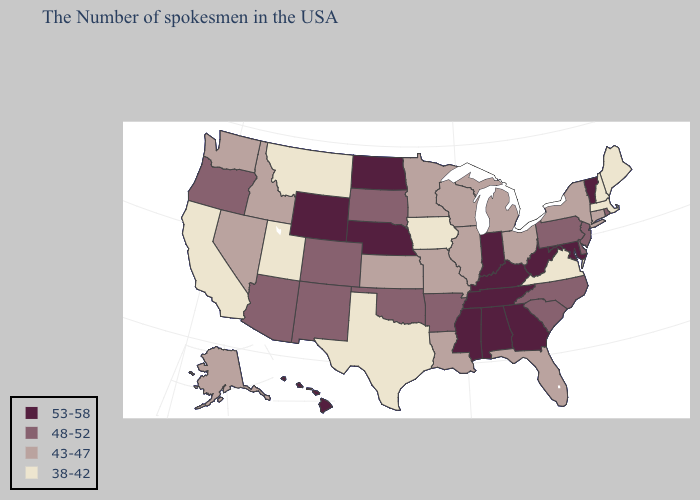Name the states that have a value in the range 38-42?
Write a very short answer. Maine, Massachusetts, New Hampshire, Virginia, Iowa, Texas, Utah, Montana, California. Does South Carolina have the highest value in the South?
Keep it brief. No. Which states have the highest value in the USA?
Write a very short answer. Vermont, Maryland, West Virginia, Georgia, Kentucky, Indiana, Alabama, Tennessee, Mississippi, Nebraska, North Dakota, Wyoming, Hawaii. What is the value of Mississippi?
Keep it brief. 53-58. Is the legend a continuous bar?
Write a very short answer. No. What is the lowest value in states that border Oklahoma?
Answer briefly. 38-42. Name the states that have a value in the range 53-58?
Keep it brief. Vermont, Maryland, West Virginia, Georgia, Kentucky, Indiana, Alabama, Tennessee, Mississippi, Nebraska, North Dakota, Wyoming, Hawaii. What is the value of Kentucky?
Short answer required. 53-58. Name the states that have a value in the range 43-47?
Be succinct. Connecticut, New York, Ohio, Florida, Michigan, Wisconsin, Illinois, Louisiana, Missouri, Minnesota, Kansas, Idaho, Nevada, Washington, Alaska. Which states have the highest value in the USA?
Concise answer only. Vermont, Maryland, West Virginia, Georgia, Kentucky, Indiana, Alabama, Tennessee, Mississippi, Nebraska, North Dakota, Wyoming, Hawaii. What is the lowest value in the USA?
Write a very short answer. 38-42. What is the value of Louisiana?
Give a very brief answer. 43-47. What is the value of Arizona?
Be succinct. 48-52. Name the states that have a value in the range 48-52?
Answer briefly. Rhode Island, New Jersey, Delaware, Pennsylvania, North Carolina, South Carolina, Arkansas, Oklahoma, South Dakota, Colorado, New Mexico, Arizona, Oregon. What is the value of Oklahoma?
Concise answer only. 48-52. 